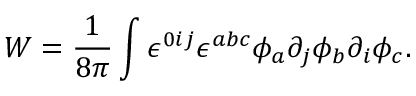Convert formula to latex. <formula><loc_0><loc_0><loc_500><loc_500>W = { \frac { 1 } { 8 \pi } } \int \epsilon ^ { 0 i j } \epsilon ^ { a b c } \phi _ { a } \partial _ { j } \phi _ { b } \partial _ { i } \phi _ { c } .</formula> 